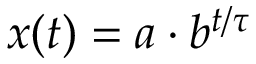<formula> <loc_0><loc_0><loc_500><loc_500>x ( t ) = a \cdot b ^ { t / \tau }</formula> 